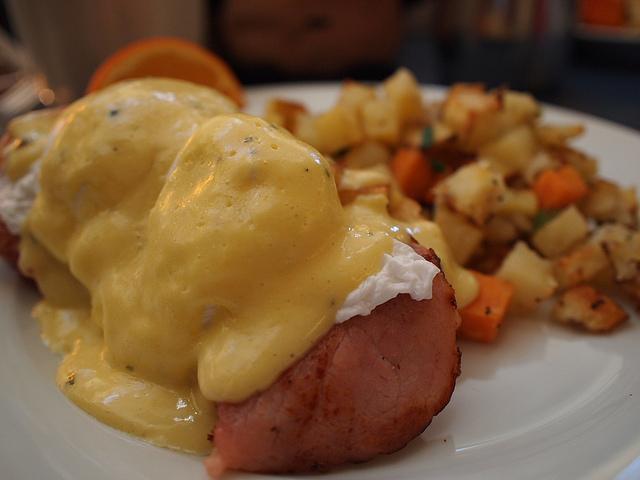How many carrots can you see?
Give a very brief answer. 1. How many people are wearing shorts?
Give a very brief answer. 0. 